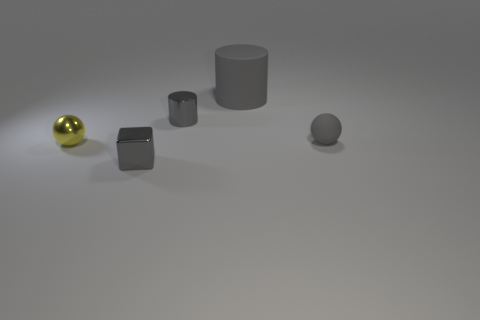What number of balls are either small gray shiny things or large brown objects?
Make the answer very short. 0. What is the color of the other metal sphere that is the same size as the gray sphere?
Your answer should be very brief. Yellow. There is a gray shiny thing that is in front of the ball to the right of the metallic cylinder; is there a tiny metal thing left of it?
Your answer should be very brief. Yes. The metallic cylinder has what size?
Ensure brevity in your answer.  Small. How many objects are gray blocks or tiny yellow things?
Offer a terse response. 2. The cylinder that is made of the same material as the small yellow object is what color?
Provide a short and direct response. Gray. Does the tiny gray object that is to the right of the gray rubber cylinder have the same shape as the big thing?
Offer a terse response. No. What number of objects are gray metallic things in front of the metallic cylinder or spheres right of the big gray object?
Give a very brief answer. 2. There is a small shiny thing that is the same shape as the large matte thing; what is its color?
Provide a succinct answer. Gray. Is there anything else that has the same shape as the big gray object?
Keep it short and to the point. Yes. 